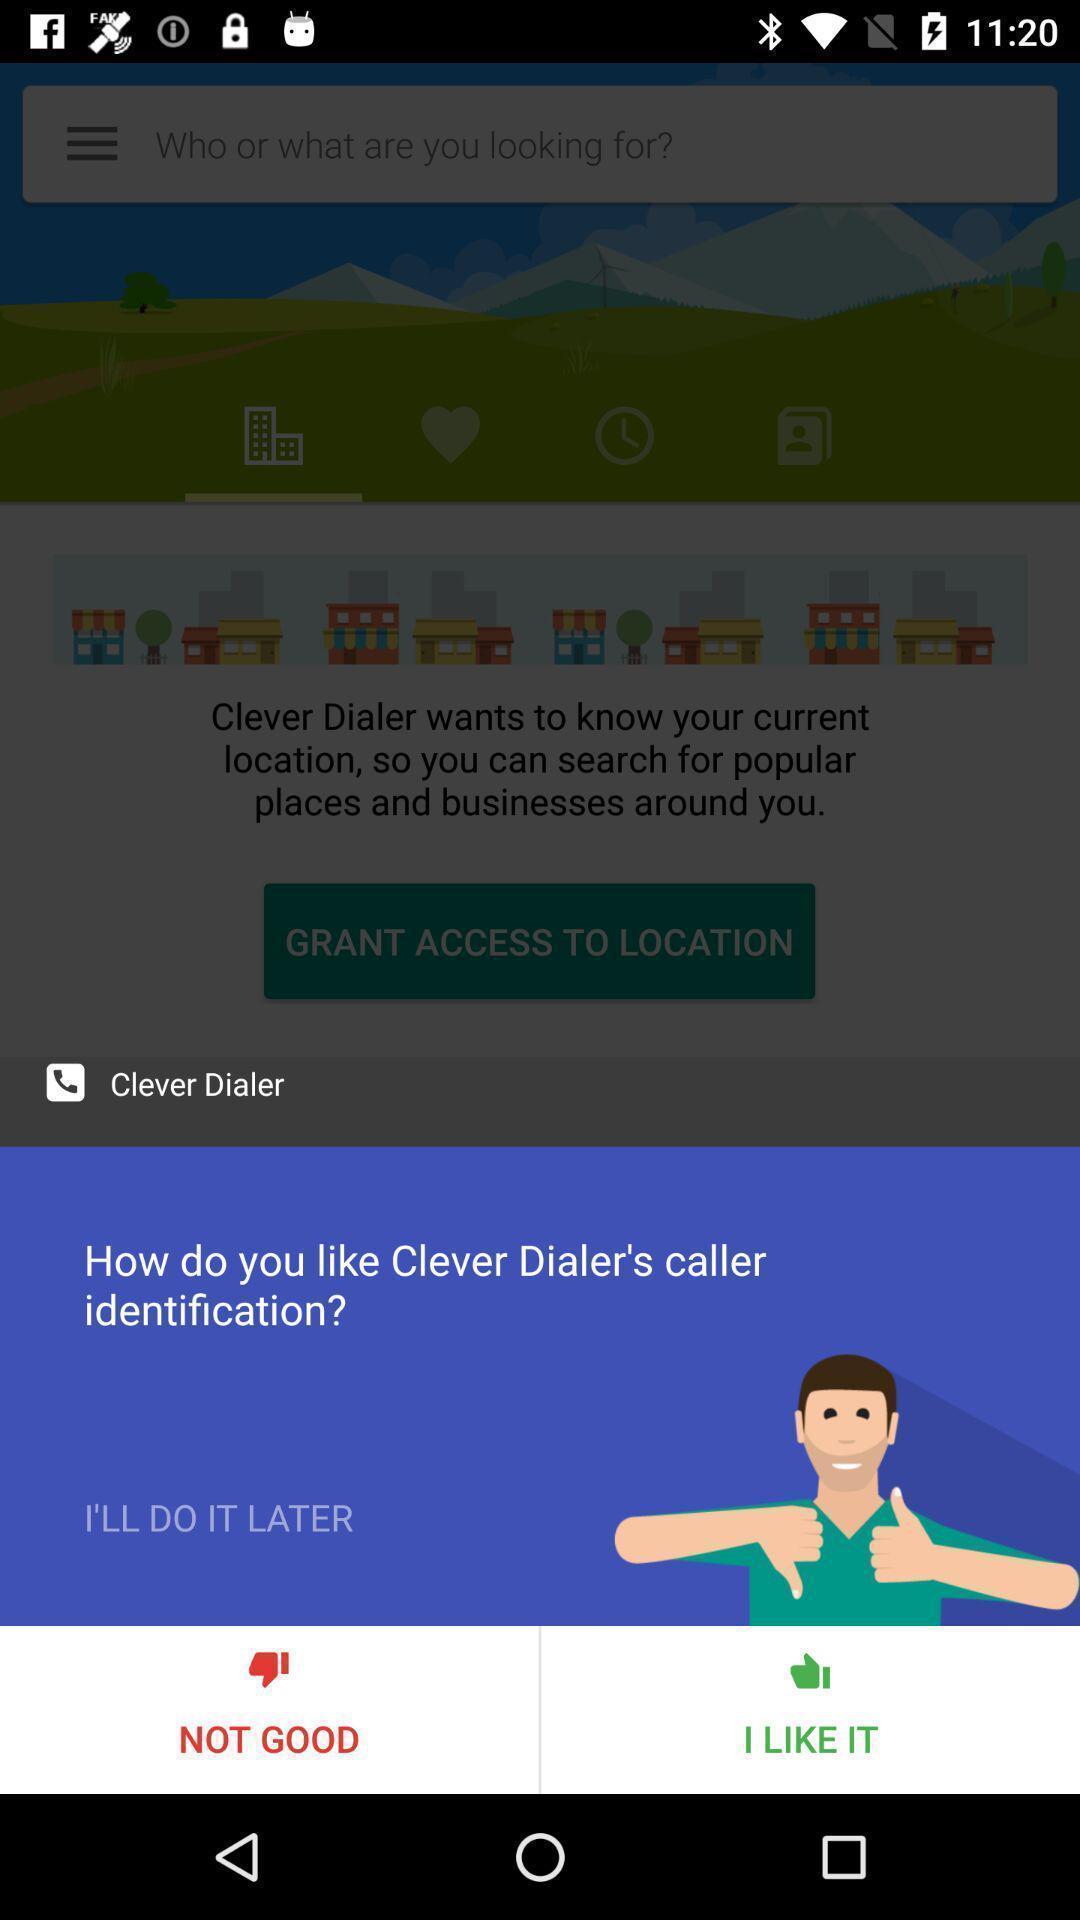Provide a detailed account of this screenshot. Popup of text to give the like for the content. 